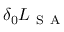<formula> <loc_0><loc_0><loc_500><loc_500>\delta _ { 0 } L _ { S A }</formula> 